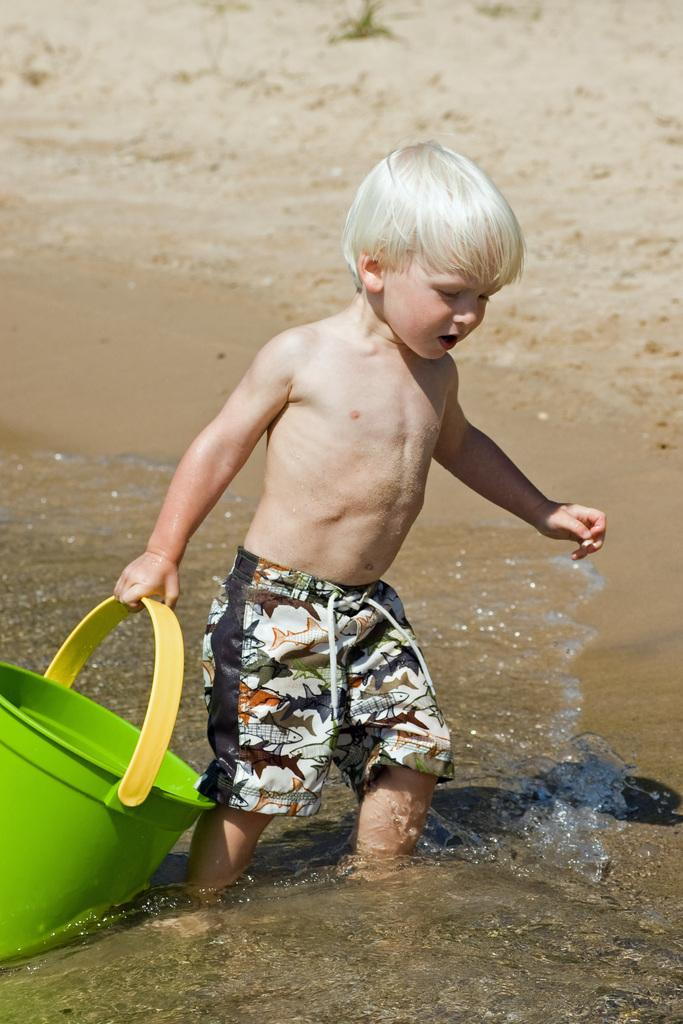Who is the main subject in the image? There is a boy in the image. What is the boy holding in the image? The boy is holding a bucket. What is the boy's hand doing in the image? The boy's hand is in the water. Where is the boy standing in the image? The boy is standing in the water. What type of plane is flying in the image? There is no plane visible in the image; it only features a boy standing in the water. 